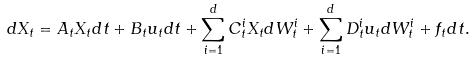<formula> <loc_0><loc_0><loc_500><loc_500>d X _ { t } = A _ { t } X _ { t } d t + B _ { t } u _ { t } d t + \sum _ { i = 1 } ^ { d } C ^ { i } _ { t } X _ { t } d W ^ { i } _ { t } + \sum _ { i = 1 } ^ { d } D ^ { i } _ { t } u _ { t } d W ^ { i } _ { t } + f _ { t } d t .</formula> 